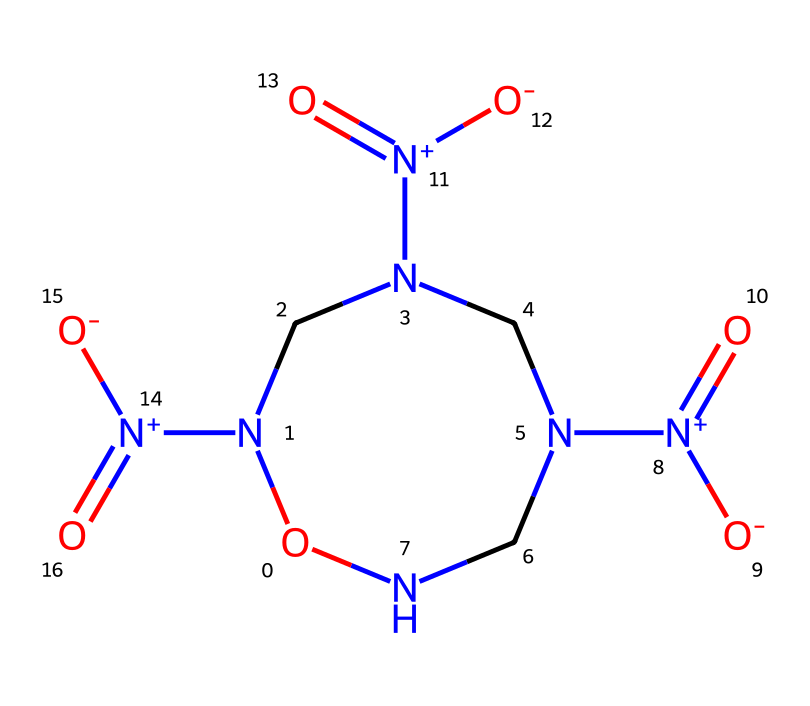What is the molecular formula of cyclonite? To determine the molecular formula, we count the number of each type of atom in the SMILES representation. The breakdown is: 6 nitrogen (N) atoms, 6 carbon (C) atoms, and 6 oxygen (O) atoms. Thus, the molecular formula is C3H6N6O6.
Answer: C3H6N6O6 How many nitrogen atoms are present in cyclonite? Upon analyzing the SMILES representation, we count the number of nitrogen (N) atoms. There are a total of 6 nitrogen atoms visible in the structure.
Answer: 6 What type of compound is cyclonite classified as? Cyclonite is a compound that contains a significant number of nitrogen atoms bonded in a unique structure, indicating it is a nitrated explosive. Specifically, due to its composition and explosive properties, cyclonite is classified as a high explosive.
Answer: high explosive What is the most prevalent functional group in cyclonite? By analyzing the SMILES structure, we can identify the functional groups present. The nitro groups (–NO2) are abundant in this compound, with four distinct –NO2 groups present, indicating they are the most prevalent.
Answer: nitro How many oxygen atoms are present in cyclonite? To count the oxygen atoms from the SMILES representation, we examine each part, finding there are 6 oxygen (O) atoms in total.
Answer: 6 